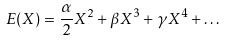<formula> <loc_0><loc_0><loc_500><loc_500>E ( X ) = \frac { \alpha } { 2 } X ^ { 2 } + \beta X ^ { 3 } + \gamma X ^ { 4 } + \dots</formula> 